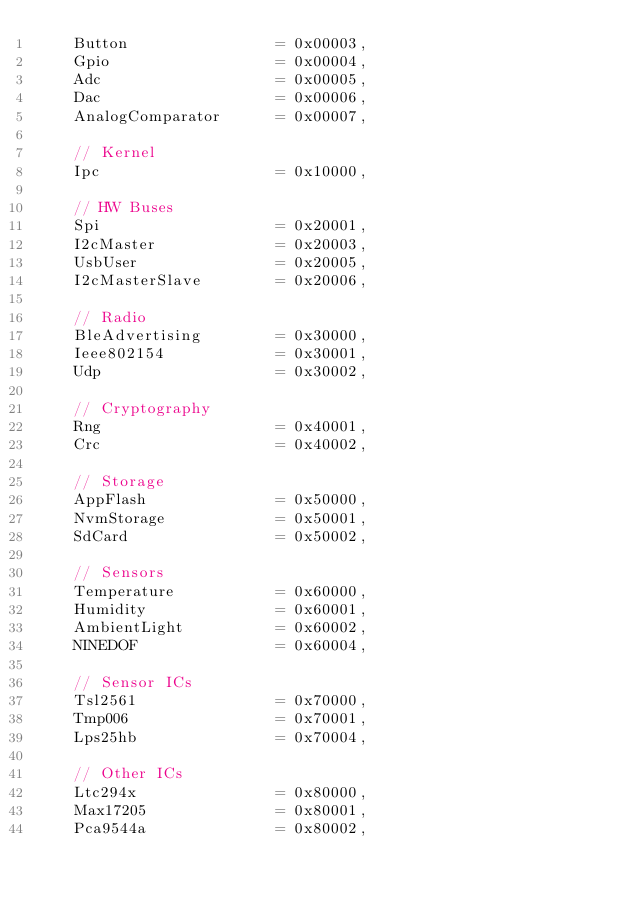Convert code to text. <code><loc_0><loc_0><loc_500><loc_500><_Rust_>    Button                = 0x00003,
    Gpio                  = 0x00004,
    Adc                   = 0x00005,
    Dac                   = 0x00006,
    AnalogComparator      = 0x00007,

    // Kernel
    Ipc                   = 0x10000,

    // HW Buses
    Spi                   = 0x20001,
    I2cMaster             = 0x20003,
    UsbUser               = 0x20005,
    I2cMasterSlave        = 0x20006,

    // Radio
    BleAdvertising        = 0x30000,
    Ieee802154            = 0x30001,
    Udp                   = 0x30002,

    // Cryptography
    Rng                   = 0x40001,
    Crc                   = 0x40002,

    // Storage
    AppFlash              = 0x50000,
    NvmStorage            = 0x50001,
    SdCard                = 0x50002,

    // Sensors
    Temperature           = 0x60000,
    Humidity              = 0x60001,
    AmbientLight          = 0x60002,
    NINEDOF               = 0x60004,

    // Sensor ICs
    Tsl2561               = 0x70000,
    Tmp006                = 0x70001,
    Lps25hb               = 0x70004,

    // Other ICs
    Ltc294x               = 0x80000,
    Max17205              = 0x80001,
    Pca9544a              = 0x80002,</code> 